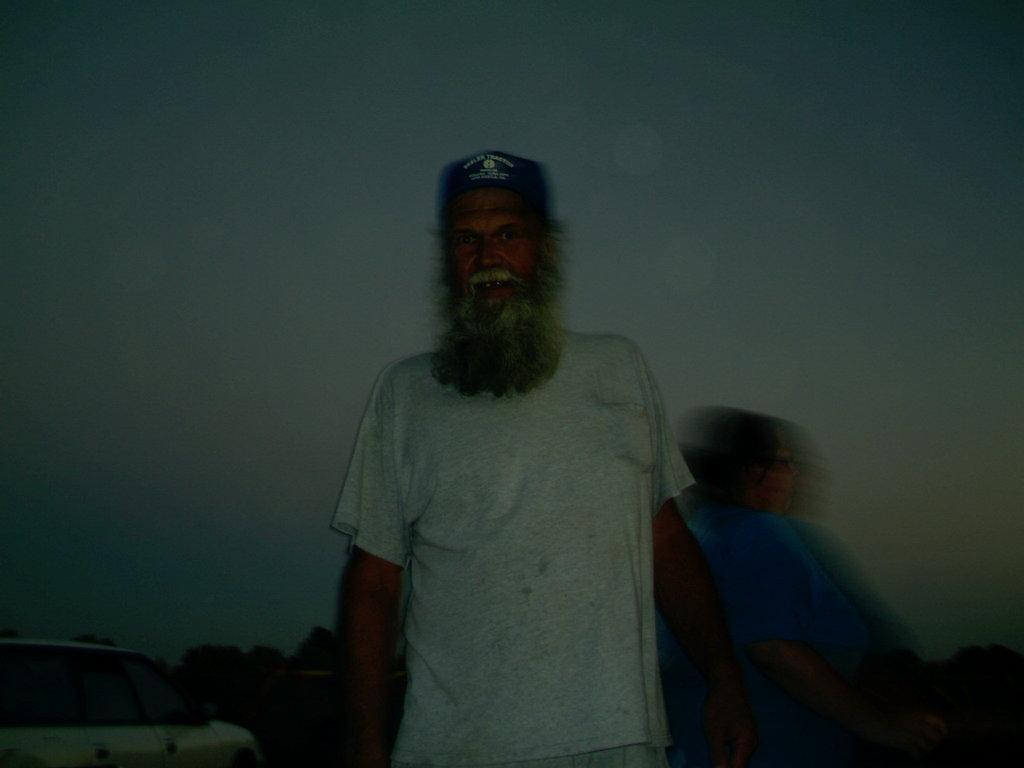Describe this image in one or two sentences. There is a man standing. Background we can see sky,car and trees. 